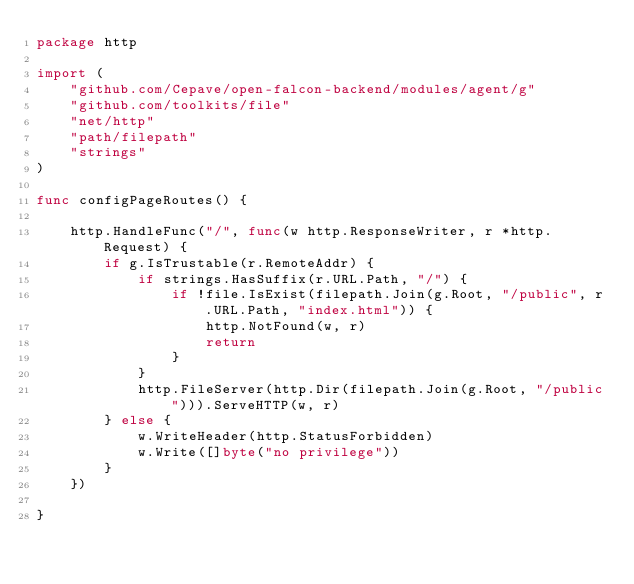<code> <loc_0><loc_0><loc_500><loc_500><_Go_>package http

import (
	"github.com/Cepave/open-falcon-backend/modules/agent/g"
	"github.com/toolkits/file"
	"net/http"
	"path/filepath"
	"strings"
)

func configPageRoutes() {

	http.HandleFunc("/", func(w http.ResponseWriter, r *http.Request) {
		if g.IsTrustable(r.RemoteAddr) {
			if strings.HasSuffix(r.URL.Path, "/") {
				if !file.IsExist(filepath.Join(g.Root, "/public", r.URL.Path, "index.html")) {
					http.NotFound(w, r)
					return
				}
			}
			http.FileServer(http.Dir(filepath.Join(g.Root, "/public"))).ServeHTTP(w, r)
		} else {
			w.WriteHeader(http.StatusForbidden)
			w.Write([]byte("no privilege"))
		}
	})

}
</code> 